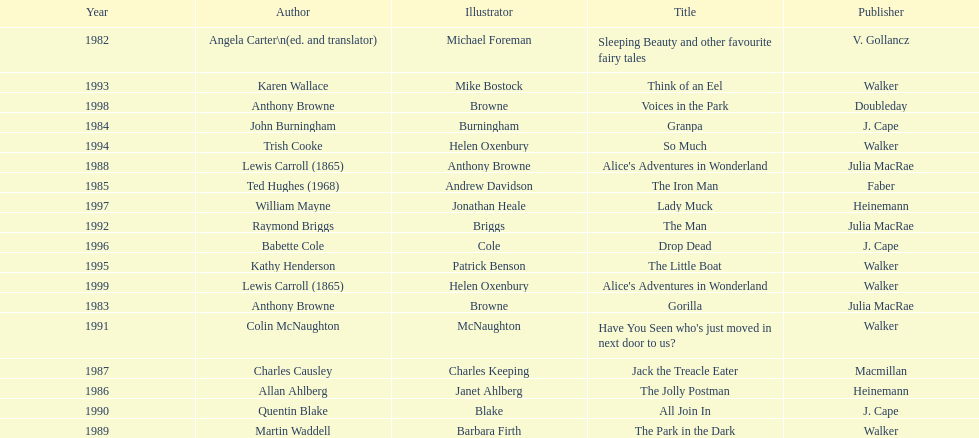Could you help me parse every detail presented in this table? {'header': ['Year', 'Author', 'Illustrator', 'Title', 'Publisher'], 'rows': [['1982', 'Angela Carter\\n(ed. and translator)', 'Michael Foreman', 'Sleeping Beauty and other favourite fairy tales', 'V. Gollancz'], ['1993', 'Karen Wallace', 'Mike Bostock', 'Think of an Eel', 'Walker'], ['1998', 'Anthony Browne', 'Browne', 'Voices in the Park', 'Doubleday'], ['1984', 'John Burningham', 'Burningham', 'Granpa', 'J. Cape'], ['1994', 'Trish Cooke', 'Helen Oxenbury', 'So Much', 'Walker'], ['1988', 'Lewis Carroll (1865)', 'Anthony Browne', "Alice's Adventures in Wonderland", 'Julia MacRae'], ['1985', 'Ted Hughes (1968)', 'Andrew Davidson', 'The Iron Man', 'Faber'], ['1997', 'William Mayne', 'Jonathan Heale', 'Lady Muck', 'Heinemann'], ['1992', 'Raymond Briggs', 'Briggs', 'The Man', 'Julia MacRae'], ['1996', 'Babette Cole', 'Cole', 'Drop Dead', 'J. Cape'], ['1995', 'Kathy Henderson', 'Patrick Benson', 'The Little Boat', 'Walker'], ['1999', 'Lewis Carroll (1865)', 'Helen Oxenbury', "Alice's Adventures in Wonderland", 'Walker'], ['1983', 'Anthony Browne', 'Browne', 'Gorilla', 'Julia MacRae'], ['1991', 'Colin McNaughton', 'McNaughton', "Have You Seen who's just moved in next door to us?", 'Walker'], ['1987', 'Charles Causley', 'Charles Keeping', 'Jack the Treacle Eater', 'Macmillan'], ['1986', 'Allan Ahlberg', 'Janet Ahlberg', 'The Jolly Postman', 'Heinemann'], ['1990', 'Quentin Blake', 'Blake', 'All Join In', 'J. Cape'], ['1989', 'Martin Waddell', 'Barbara Firth', 'The Park in the Dark', 'Walker']]} Which other author, besides lewis carroll, has won the kurt maschler award twice? Anthony Browne. 